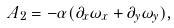<formula> <loc_0><loc_0><loc_500><loc_500>A _ { 2 } = - \alpha ( \partial _ { x } \omega _ { x } + \partial _ { y } \omega _ { y } ) ,</formula> 